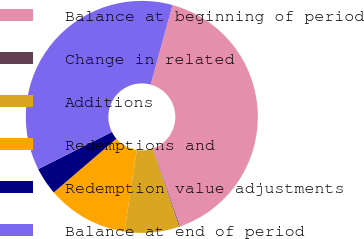<chart> <loc_0><loc_0><loc_500><loc_500><pie_chart><fcel>Balance at beginning of period<fcel>Change in related<fcel>Additions<fcel>Redemptions and<fcel>Redemption value adjustments<fcel>Balance at end of period<nl><fcel>40.42%<fcel>0.12%<fcel>7.59%<fcel>11.33%<fcel>3.85%<fcel>36.69%<nl></chart> 